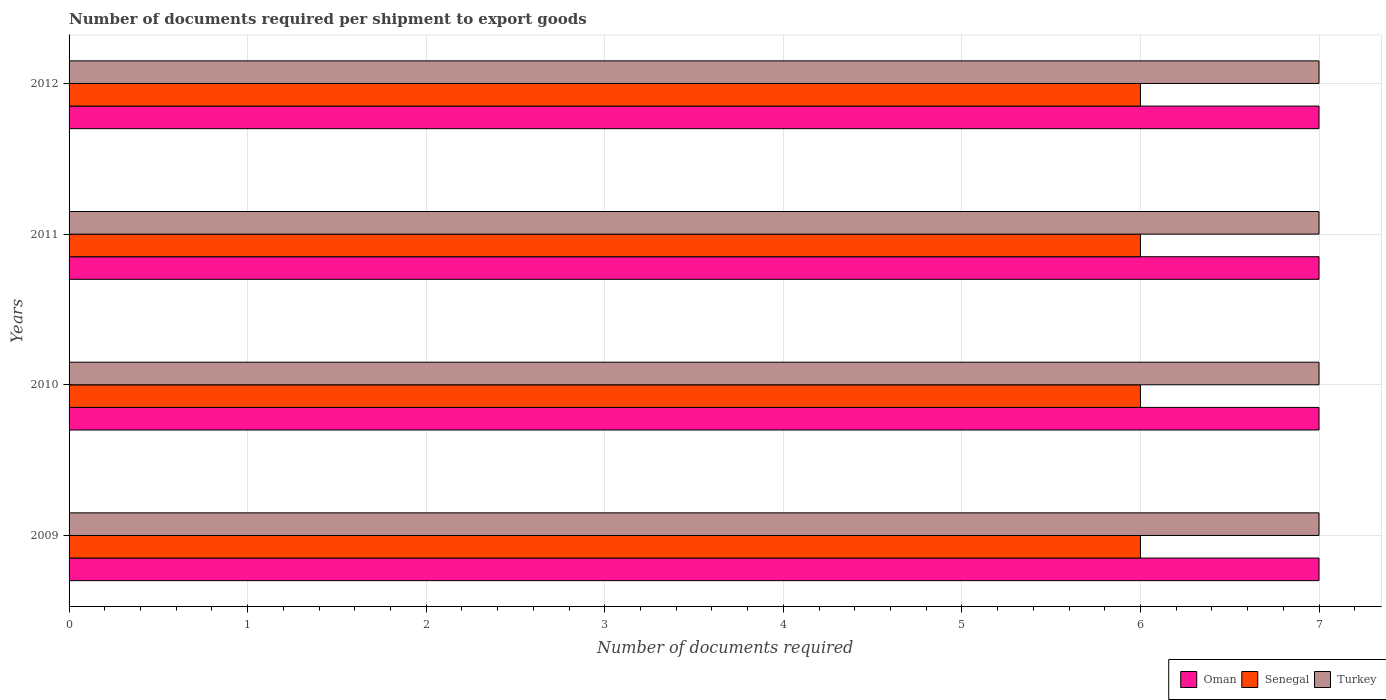Are the number of bars on each tick of the Y-axis equal?
Offer a terse response. Yes. How many bars are there on the 2nd tick from the top?
Ensure brevity in your answer.  3. How many bars are there on the 1st tick from the bottom?
Offer a terse response. 3. What is the number of documents required per shipment to export goods in Turkey in 2012?
Ensure brevity in your answer.  7. Across all years, what is the minimum number of documents required per shipment to export goods in Senegal?
Your answer should be very brief. 6. What is the total number of documents required per shipment to export goods in Turkey in the graph?
Your answer should be compact. 28. What is the difference between the number of documents required per shipment to export goods in Oman in 2009 and that in 2010?
Provide a short and direct response. 0. What is the difference between the number of documents required per shipment to export goods in Senegal in 2010 and the number of documents required per shipment to export goods in Oman in 2012?
Offer a terse response. -1. What is the average number of documents required per shipment to export goods in Oman per year?
Ensure brevity in your answer.  7. In the year 2010, what is the difference between the number of documents required per shipment to export goods in Senegal and number of documents required per shipment to export goods in Oman?
Offer a very short reply. -1. In how many years, is the number of documents required per shipment to export goods in Senegal greater than 2 ?
Your answer should be very brief. 4. Is the number of documents required per shipment to export goods in Oman in 2010 less than that in 2012?
Give a very brief answer. No. Is the difference between the number of documents required per shipment to export goods in Senegal in 2010 and 2012 greater than the difference between the number of documents required per shipment to export goods in Oman in 2010 and 2012?
Ensure brevity in your answer.  No. What is the difference between the highest and the second highest number of documents required per shipment to export goods in Oman?
Offer a very short reply. 0. Is the sum of the number of documents required per shipment to export goods in Turkey in 2009 and 2011 greater than the maximum number of documents required per shipment to export goods in Oman across all years?
Give a very brief answer. Yes. What does the 2nd bar from the top in 2010 represents?
Give a very brief answer. Senegal. What does the 3rd bar from the bottom in 2012 represents?
Your response must be concise. Turkey. Is it the case that in every year, the sum of the number of documents required per shipment to export goods in Senegal and number of documents required per shipment to export goods in Turkey is greater than the number of documents required per shipment to export goods in Oman?
Offer a very short reply. Yes. How many bars are there?
Provide a short and direct response. 12. How many years are there in the graph?
Provide a succinct answer. 4. Are the values on the major ticks of X-axis written in scientific E-notation?
Keep it short and to the point. No. Does the graph contain grids?
Keep it short and to the point. Yes. How are the legend labels stacked?
Your answer should be compact. Horizontal. What is the title of the graph?
Provide a succinct answer. Number of documents required per shipment to export goods. Does "Dominican Republic" appear as one of the legend labels in the graph?
Offer a very short reply. No. What is the label or title of the X-axis?
Offer a very short reply. Number of documents required. What is the Number of documents required in Oman in 2009?
Your answer should be compact. 7. What is the Number of documents required in Senegal in 2009?
Make the answer very short. 6. What is the Number of documents required in Turkey in 2009?
Your answer should be compact. 7. What is the Number of documents required of Oman in 2010?
Keep it short and to the point. 7. What is the Number of documents required of Oman in 2012?
Make the answer very short. 7. What is the Number of documents required of Senegal in 2012?
Offer a terse response. 6. What is the Number of documents required of Turkey in 2012?
Provide a succinct answer. 7. Across all years, what is the maximum Number of documents required of Senegal?
Your response must be concise. 6. Across all years, what is the minimum Number of documents required in Senegal?
Give a very brief answer. 6. What is the total Number of documents required in Senegal in the graph?
Your answer should be compact. 24. What is the total Number of documents required in Turkey in the graph?
Offer a terse response. 28. What is the difference between the Number of documents required in Turkey in 2009 and that in 2010?
Your answer should be very brief. 0. What is the difference between the Number of documents required in Senegal in 2009 and that in 2011?
Make the answer very short. 0. What is the difference between the Number of documents required of Senegal in 2009 and that in 2012?
Offer a terse response. 0. What is the difference between the Number of documents required of Turkey in 2009 and that in 2012?
Give a very brief answer. 0. What is the difference between the Number of documents required in Oman in 2010 and that in 2011?
Provide a short and direct response. 0. What is the difference between the Number of documents required of Turkey in 2010 and that in 2011?
Your answer should be compact. 0. What is the difference between the Number of documents required of Oman in 2010 and that in 2012?
Offer a terse response. 0. What is the difference between the Number of documents required of Turkey in 2010 and that in 2012?
Offer a terse response. 0. What is the difference between the Number of documents required of Oman in 2011 and that in 2012?
Your answer should be compact. 0. What is the difference between the Number of documents required in Senegal in 2011 and that in 2012?
Give a very brief answer. 0. What is the difference between the Number of documents required in Oman in 2009 and the Number of documents required in Senegal in 2010?
Keep it short and to the point. 1. What is the difference between the Number of documents required of Oman in 2009 and the Number of documents required of Turkey in 2010?
Your answer should be compact. 0. What is the difference between the Number of documents required of Oman in 2009 and the Number of documents required of Turkey in 2012?
Provide a short and direct response. 0. What is the difference between the Number of documents required in Senegal in 2009 and the Number of documents required in Turkey in 2012?
Your answer should be very brief. -1. What is the difference between the Number of documents required in Oman in 2010 and the Number of documents required in Senegal in 2011?
Your answer should be very brief. 1. What is the difference between the Number of documents required of Senegal in 2010 and the Number of documents required of Turkey in 2011?
Give a very brief answer. -1. What is the difference between the Number of documents required in Oman in 2010 and the Number of documents required in Turkey in 2012?
Give a very brief answer. 0. What is the difference between the Number of documents required in Senegal in 2010 and the Number of documents required in Turkey in 2012?
Offer a very short reply. -1. What is the difference between the Number of documents required in Oman in 2011 and the Number of documents required in Senegal in 2012?
Your response must be concise. 1. What is the average Number of documents required of Oman per year?
Offer a very short reply. 7. What is the average Number of documents required in Turkey per year?
Ensure brevity in your answer.  7. In the year 2009, what is the difference between the Number of documents required of Oman and Number of documents required of Senegal?
Offer a terse response. 1. In the year 2009, what is the difference between the Number of documents required of Oman and Number of documents required of Turkey?
Keep it short and to the point. 0. In the year 2009, what is the difference between the Number of documents required in Senegal and Number of documents required in Turkey?
Provide a succinct answer. -1. In the year 2010, what is the difference between the Number of documents required in Oman and Number of documents required in Turkey?
Offer a very short reply. 0. In the year 2010, what is the difference between the Number of documents required of Senegal and Number of documents required of Turkey?
Give a very brief answer. -1. In the year 2011, what is the difference between the Number of documents required in Oman and Number of documents required in Senegal?
Offer a terse response. 1. In the year 2011, what is the difference between the Number of documents required of Senegal and Number of documents required of Turkey?
Offer a terse response. -1. In the year 2012, what is the difference between the Number of documents required of Senegal and Number of documents required of Turkey?
Provide a short and direct response. -1. What is the ratio of the Number of documents required of Oman in 2009 to that in 2011?
Offer a very short reply. 1. What is the ratio of the Number of documents required in Senegal in 2009 to that in 2011?
Ensure brevity in your answer.  1. What is the ratio of the Number of documents required of Oman in 2009 to that in 2012?
Your answer should be very brief. 1. What is the ratio of the Number of documents required of Turkey in 2009 to that in 2012?
Give a very brief answer. 1. What is the ratio of the Number of documents required in Senegal in 2010 to that in 2011?
Offer a very short reply. 1. What is the ratio of the Number of documents required in Turkey in 2010 to that in 2011?
Your response must be concise. 1. What is the ratio of the Number of documents required in Oman in 2011 to that in 2012?
Give a very brief answer. 1. What is the ratio of the Number of documents required in Senegal in 2011 to that in 2012?
Provide a short and direct response. 1. What is the difference between the highest and the second highest Number of documents required of Oman?
Your answer should be very brief. 0. What is the difference between the highest and the lowest Number of documents required of Oman?
Your answer should be compact. 0. What is the difference between the highest and the lowest Number of documents required of Senegal?
Offer a terse response. 0. What is the difference between the highest and the lowest Number of documents required in Turkey?
Provide a succinct answer. 0. 